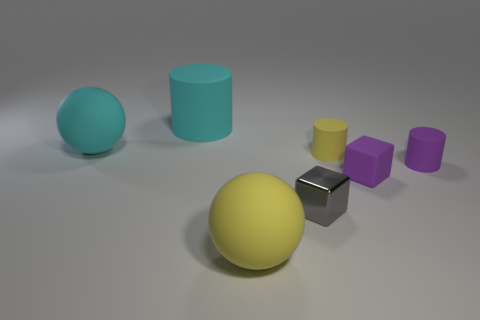Add 2 tiny shiny things. How many objects exist? 9 Subtract all cubes. How many objects are left? 5 Add 3 yellow balls. How many yellow balls exist? 4 Subtract 0 green blocks. How many objects are left? 7 Subtract all purple rubber cylinders. Subtract all small purple rubber things. How many objects are left? 4 Add 3 rubber spheres. How many rubber spheres are left? 5 